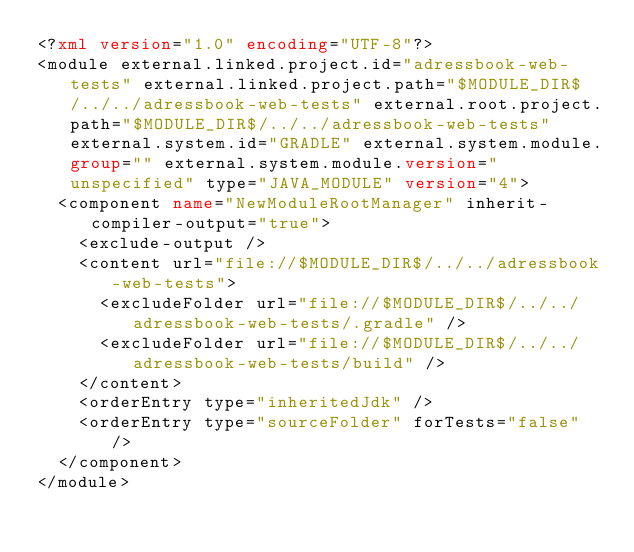<code> <loc_0><loc_0><loc_500><loc_500><_XML_><?xml version="1.0" encoding="UTF-8"?>
<module external.linked.project.id="adressbook-web-tests" external.linked.project.path="$MODULE_DIR$/../../adressbook-web-tests" external.root.project.path="$MODULE_DIR$/../../adressbook-web-tests" external.system.id="GRADLE" external.system.module.group="" external.system.module.version="unspecified" type="JAVA_MODULE" version="4">
  <component name="NewModuleRootManager" inherit-compiler-output="true">
    <exclude-output />
    <content url="file://$MODULE_DIR$/../../adressbook-web-tests">
      <excludeFolder url="file://$MODULE_DIR$/../../adressbook-web-tests/.gradle" />
      <excludeFolder url="file://$MODULE_DIR$/../../adressbook-web-tests/build" />
    </content>
    <orderEntry type="inheritedJdk" />
    <orderEntry type="sourceFolder" forTests="false" />
  </component>
</module></code> 